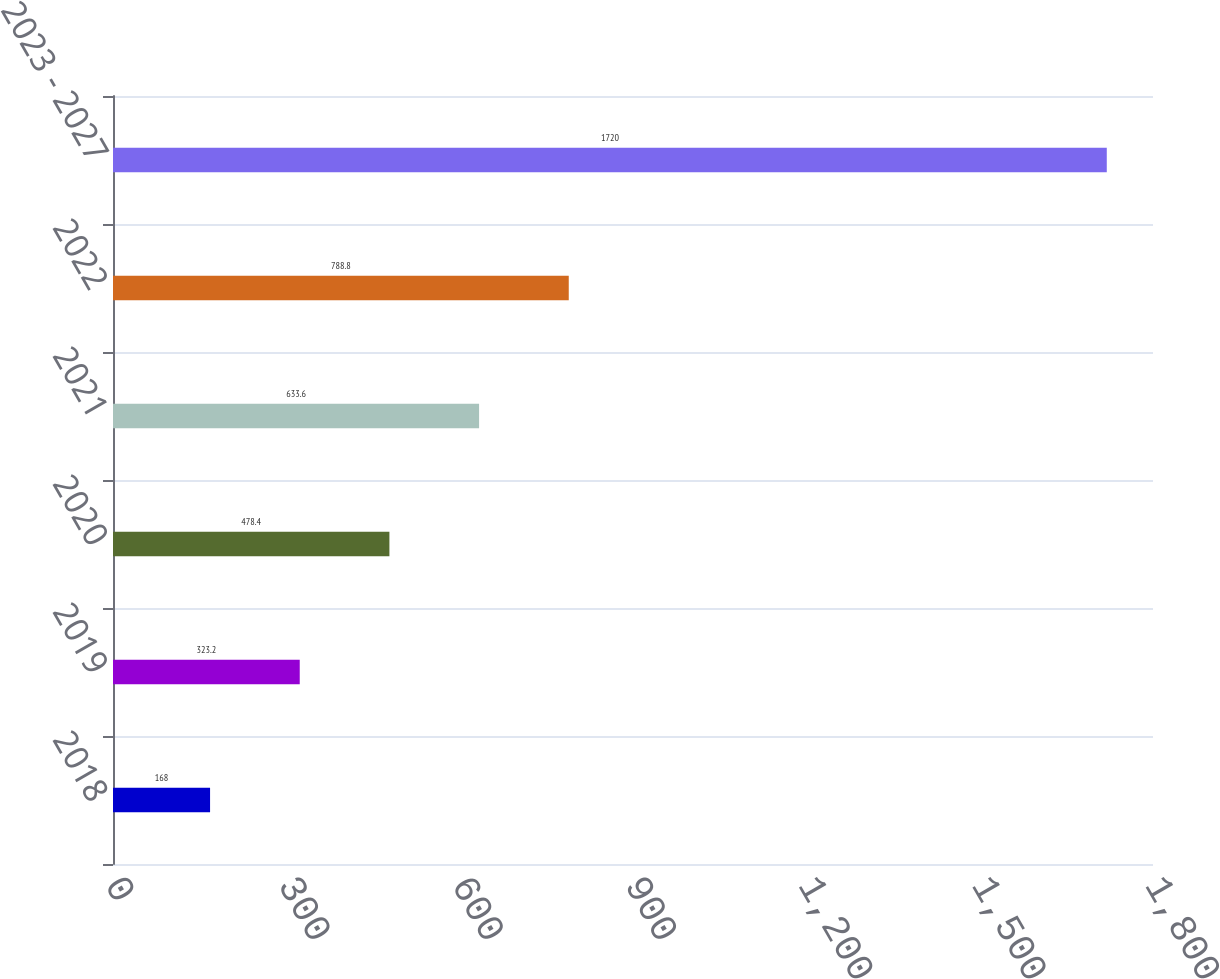Convert chart to OTSL. <chart><loc_0><loc_0><loc_500><loc_500><bar_chart><fcel>2018<fcel>2019<fcel>2020<fcel>2021<fcel>2022<fcel>2023 - 2027<nl><fcel>168<fcel>323.2<fcel>478.4<fcel>633.6<fcel>788.8<fcel>1720<nl></chart> 